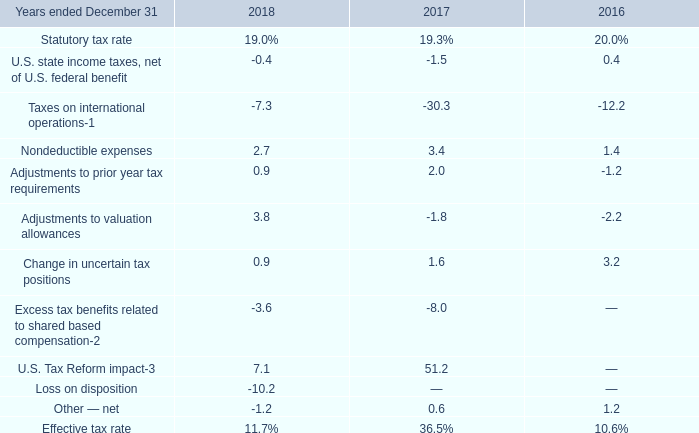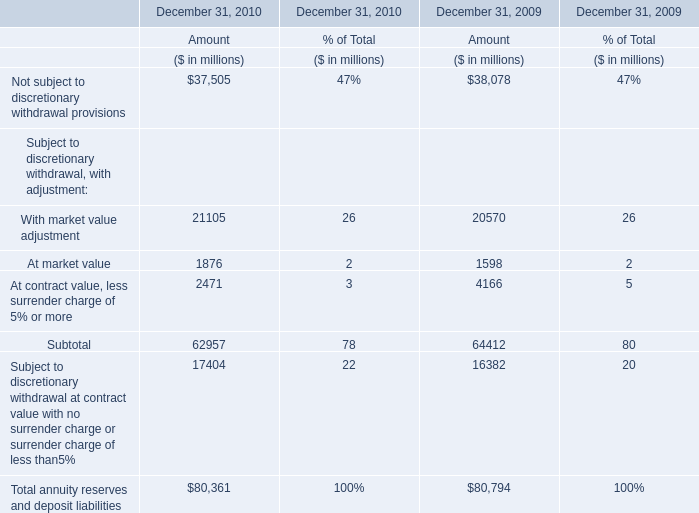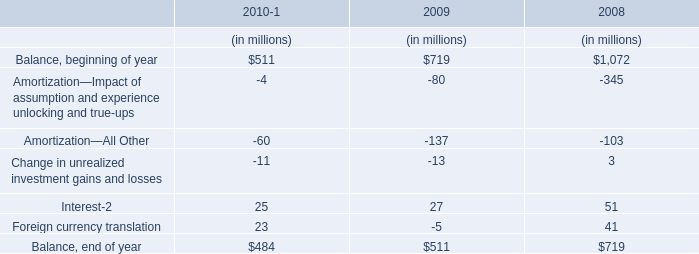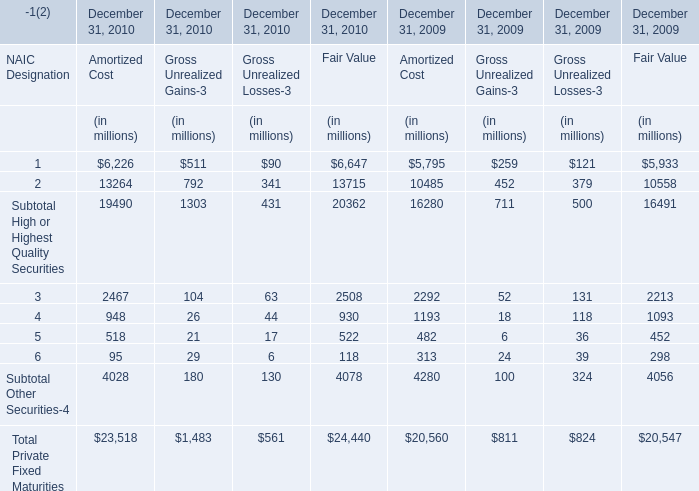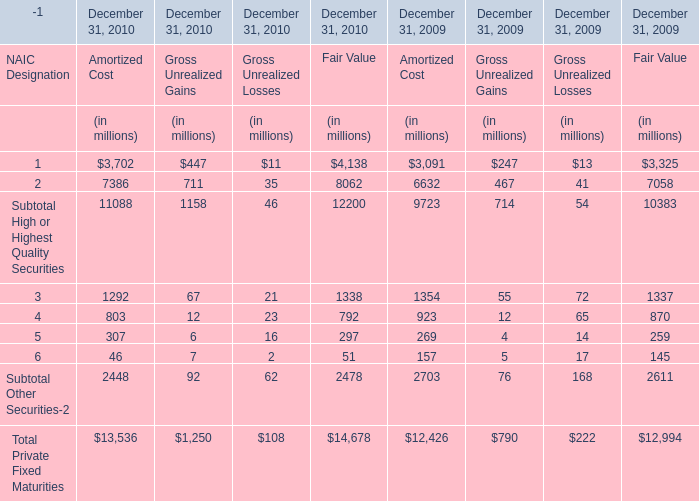What is the sum of Amortized Cost, Gross Unrealized Gains and Gross Unrealized Losses in 2010 for Subtotal High or Highest Quality Securities ? (in million) 
Computations: ((11088 + 1158) - 46)
Answer: 12200.0. 